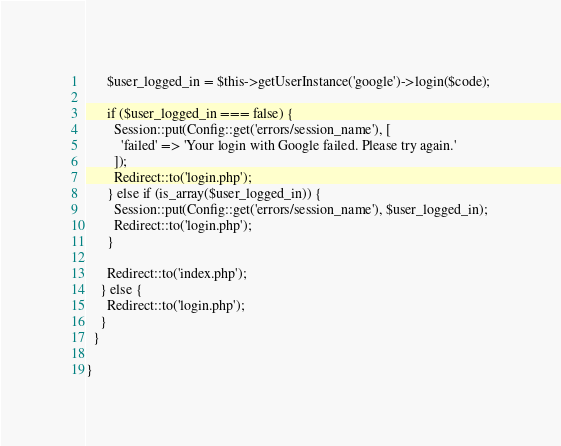Convert code to text. <code><loc_0><loc_0><loc_500><loc_500><_PHP_>
      $user_logged_in = $this->getUserInstance('google')->login($code);

      if ($user_logged_in === false) {
        Session::put(Config::get('errors/session_name'), [
          'failed' => 'Your login with Google failed. Please try again.'
        ]);
        Redirect::to('login.php');
      } else if (is_array($user_logged_in)) {
        Session::put(Config::get('errors/session_name'), $user_logged_in);
        Redirect::to('login.php');
      }

      Redirect::to('index.php');
    } else {
      Redirect::to('login.php');
    }
  }

}
</code> 